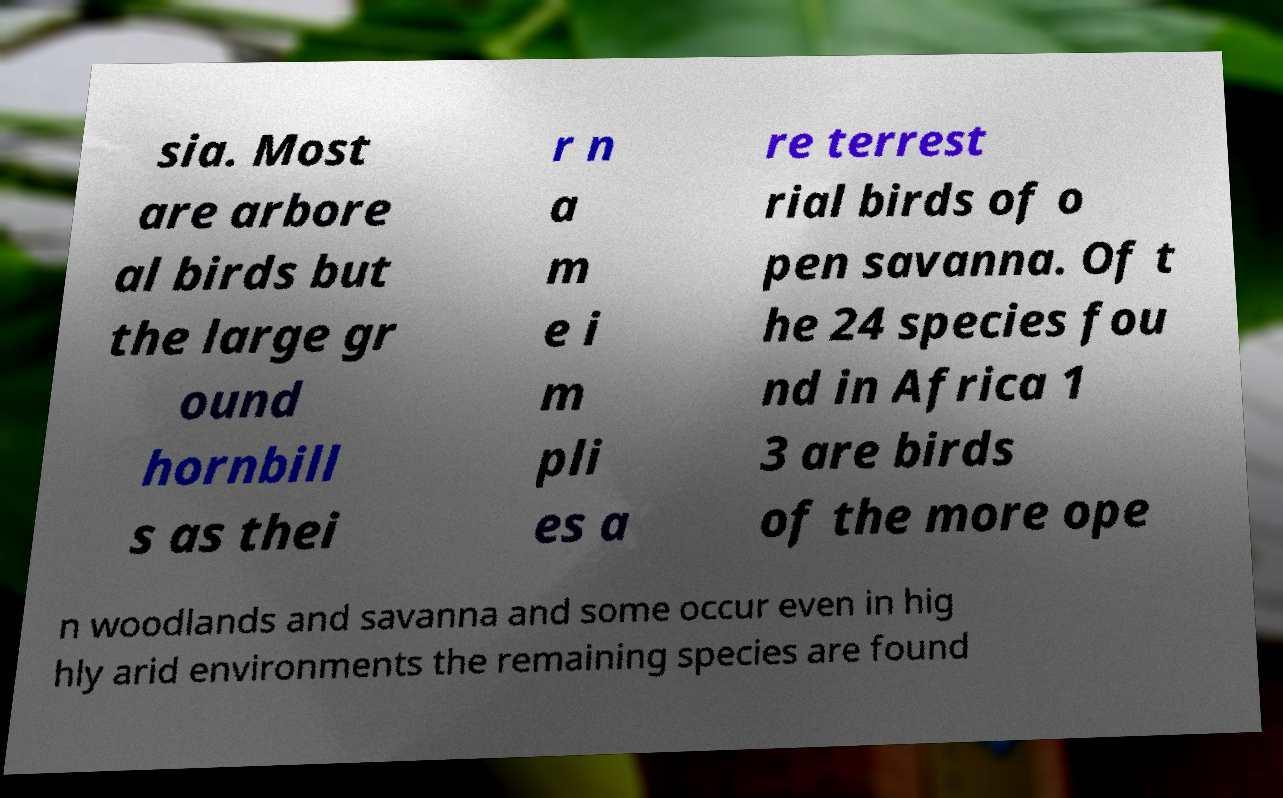Please read and relay the text visible in this image. What does it say? sia. Most are arbore al birds but the large gr ound hornbill s as thei r n a m e i m pli es a re terrest rial birds of o pen savanna. Of t he 24 species fou nd in Africa 1 3 are birds of the more ope n woodlands and savanna and some occur even in hig hly arid environments the remaining species are found 